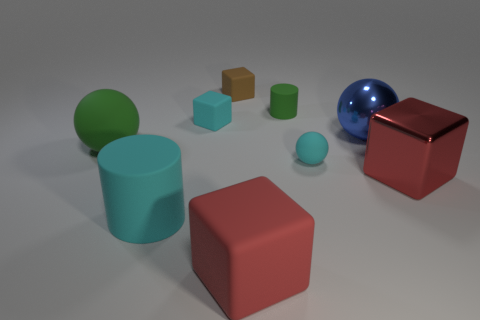Subtract all big balls. How many balls are left? 1 Add 1 large blue things. How many objects exist? 10 Subtract all cyan cylinders. How many cylinders are left? 1 Subtract 2 cylinders. How many cylinders are left? 0 Subtract all purple cubes. Subtract all cyan cylinders. How many cubes are left? 4 Subtract all cyan cylinders. How many red spheres are left? 0 Subtract all gray matte things. Subtract all large red rubber cubes. How many objects are left? 8 Add 5 tiny green matte cylinders. How many tiny green matte cylinders are left? 6 Add 9 large red matte cubes. How many large red matte cubes exist? 10 Subtract 0 yellow spheres. How many objects are left? 9 